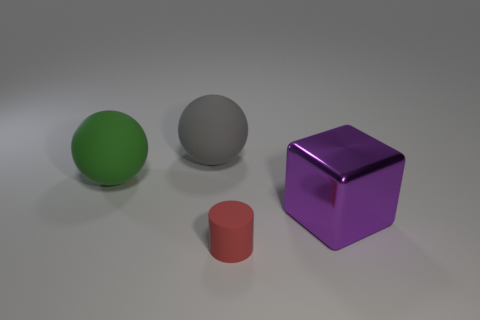Add 4 large gray balls. How many objects exist? 8 Subtract all cylinders. How many objects are left? 3 Subtract all red metal blocks. Subtract all blocks. How many objects are left? 3 Add 1 big spheres. How many big spheres are left? 3 Add 2 large yellow things. How many large yellow things exist? 2 Subtract 0 yellow cylinders. How many objects are left? 4 